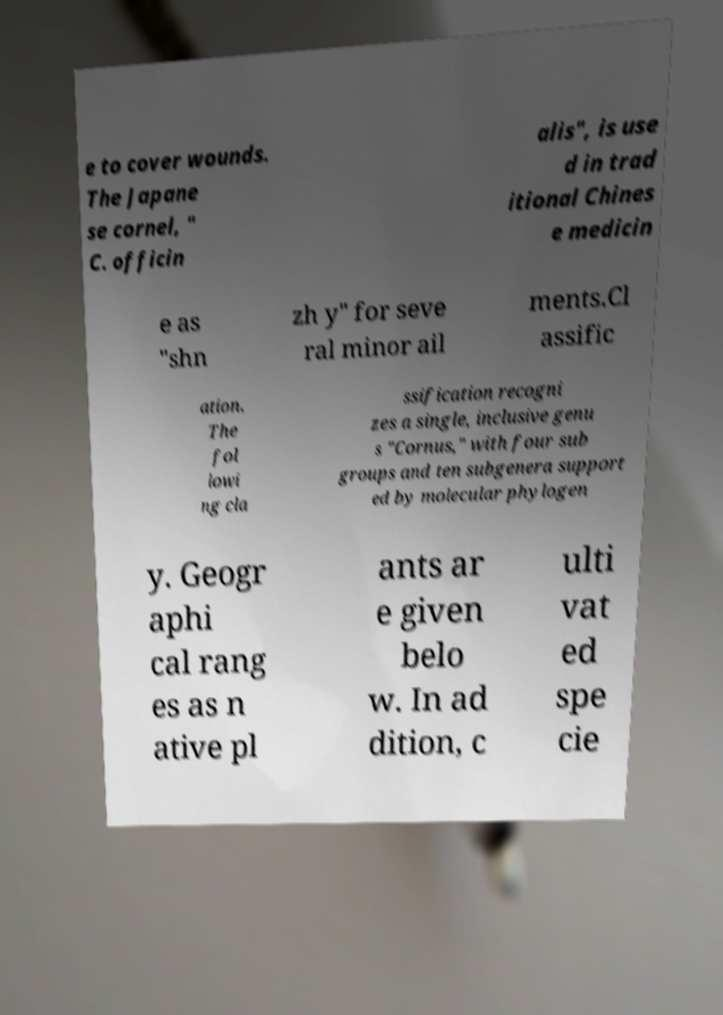There's text embedded in this image that I need extracted. Can you transcribe it verbatim? e to cover wounds. The Japane se cornel, " C. officin alis", is use d in trad itional Chines e medicin e as "shn zh y" for seve ral minor ail ments.Cl assific ation. The fol lowi ng cla ssification recogni zes a single, inclusive genu s "Cornus," with four sub groups and ten subgenera support ed by molecular phylogen y. Geogr aphi cal rang es as n ative pl ants ar e given belo w. In ad dition, c ulti vat ed spe cie 